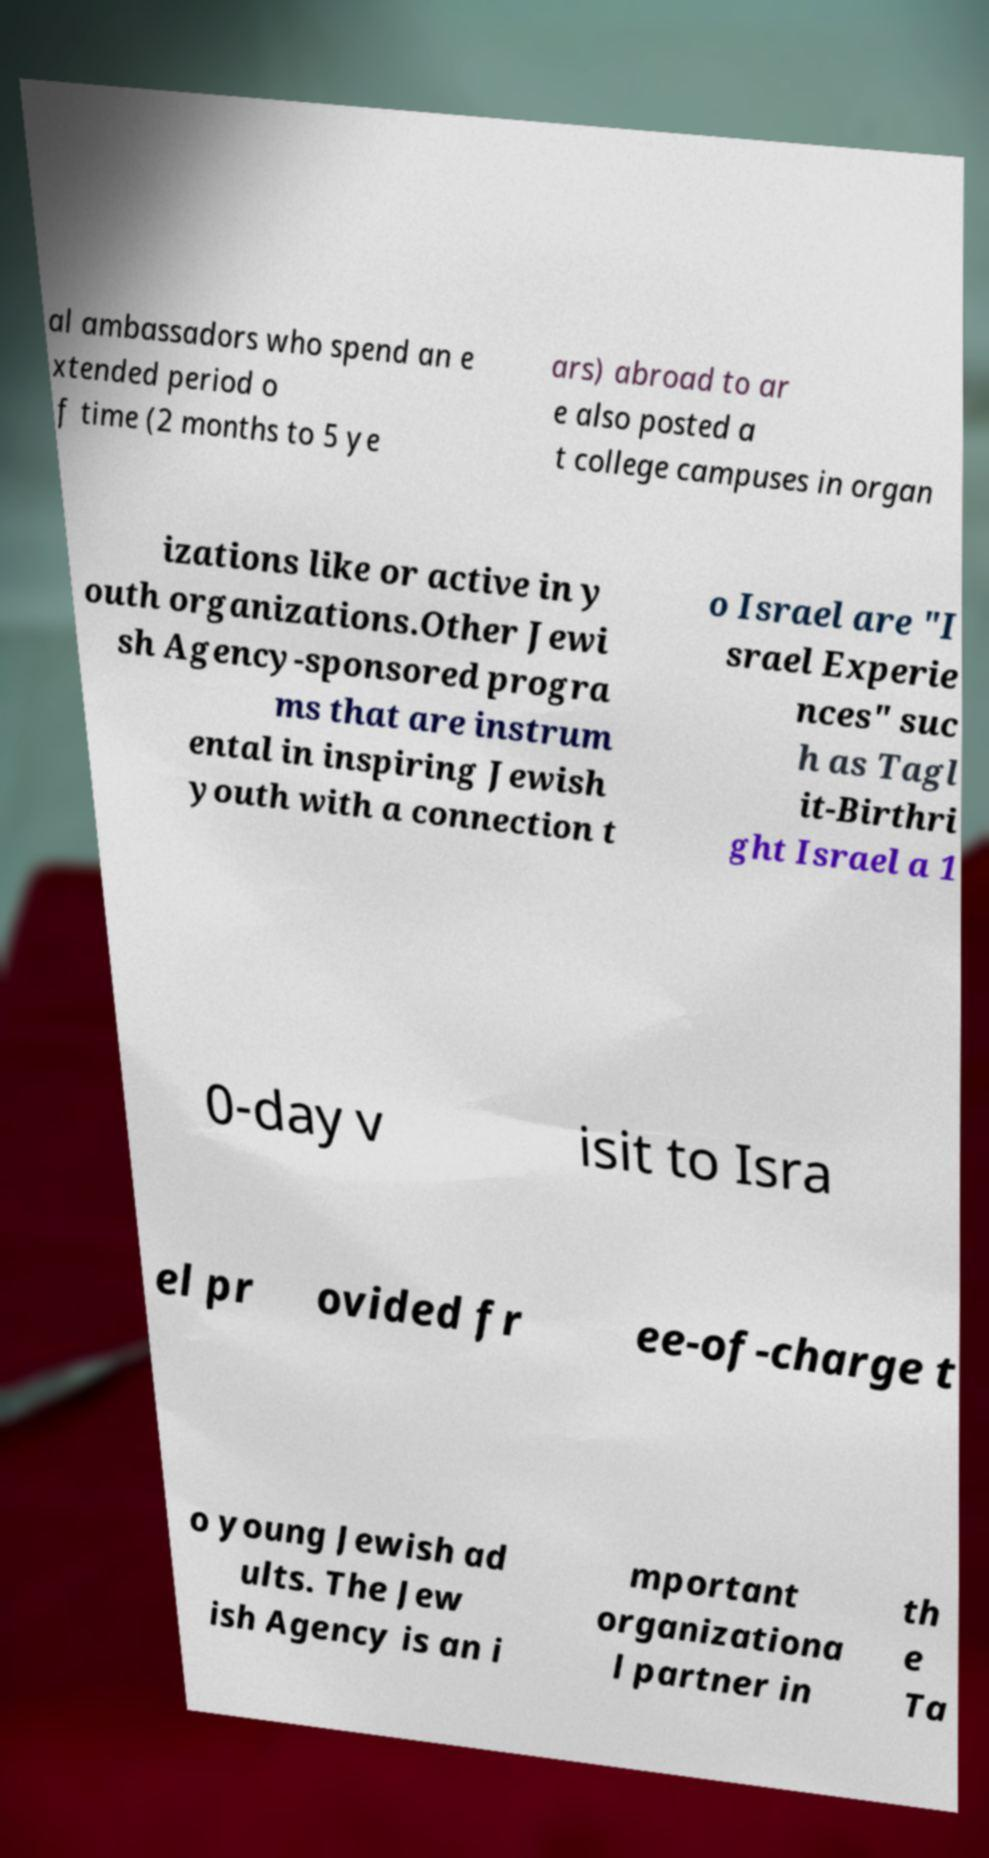Please identify and transcribe the text found in this image. al ambassadors who spend an e xtended period o f time (2 months to 5 ye ars) abroad to ar e also posted a t college campuses in organ izations like or active in y outh organizations.Other Jewi sh Agency-sponsored progra ms that are instrum ental in inspiring Jewish youth with a connection t o Israel are "I srael Experie nces" suc h as Tagl it-Birthri ght Israel a 1 0-day v isit to Isra el pr ovided fr ee-of-charge t o young Jewish ad ults. The Jew ish Agency is an i mportant organizationa l partner in th e Ta 